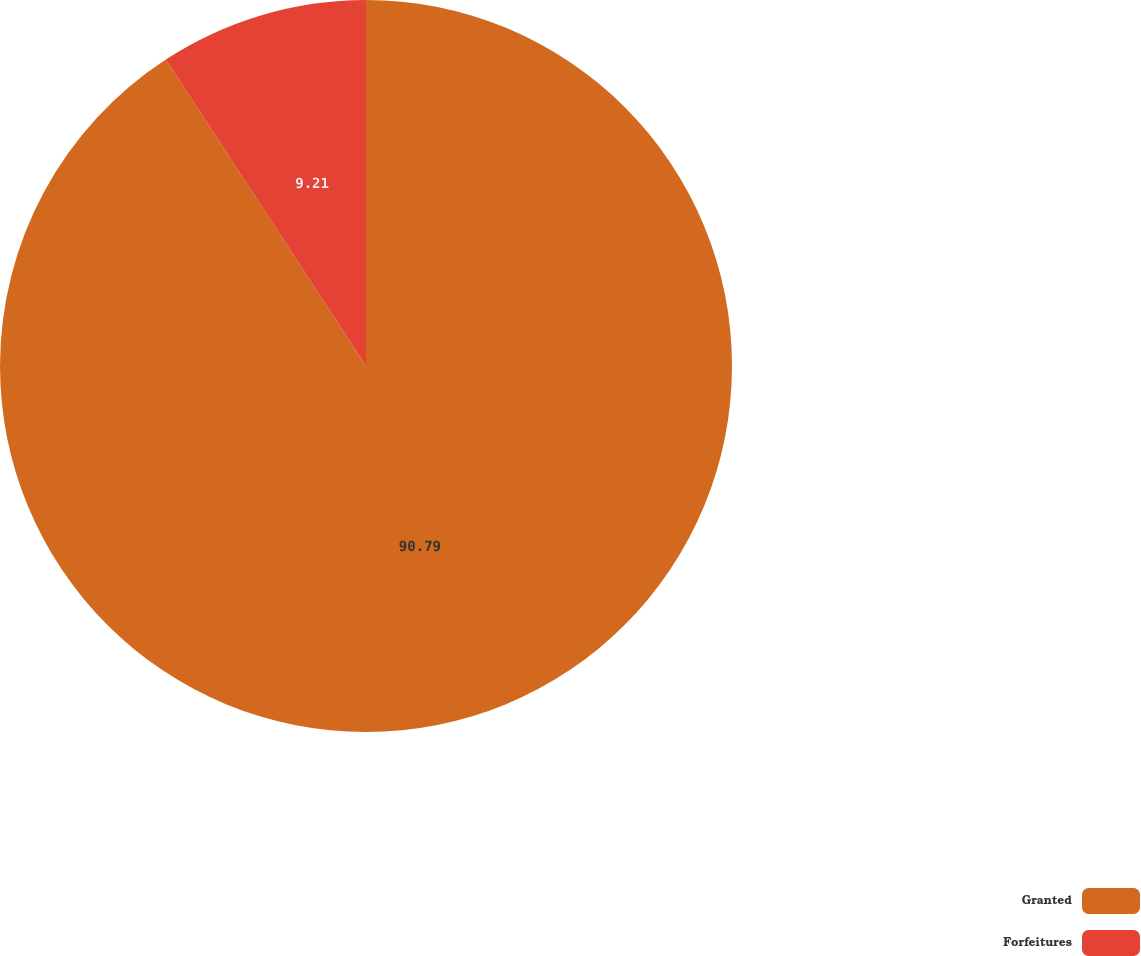<chart> <loc_0><loc_0><loc_500><loc_500><pie_chart><fcel>Granted<fcel>Forfeitures<nl><fcel>90.79%<fcel>9.21%<nl></chart> 